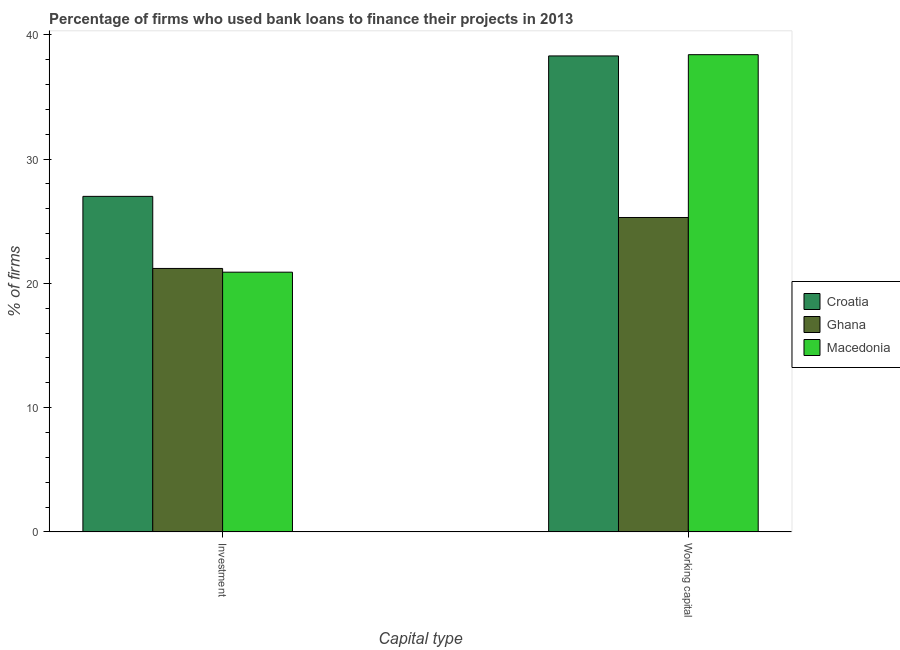How many different coloured bars are there?
Provide a succinct answer. 3. How many groups of bars are there?
Give a very brief answer. 2. What is the label of the 2nd group of bars from the left?
Your answer should be very brief. Working capital. What is the percentage of firms using banks to finance investment in Ghana?
Give a very brief answer. 21.2. Across all countries, what is the maximum percentage of firms using banks to finance working capital?
Keep it short and to the point. 38.4. Across all countries, what is the minimum percentage of firms using banks to finance working capital?
Keep it short and to the point. 25.3. In which country was the percentage of firms using banks to finance investment maximum?
Offer a very short reply. Croatia. What is the total percentage of firms using banks to finance working capital in the graph?
Your answer should be very brief. 102. What is the difference between the percentage of firms using banks to finance investment in Croatia and that in Ghana?
Your answer should be very brief. 5.8. What is the difference between the percentage of firms using banks to finance investment in Macedonia and the percentage of firms using banks to finance working capital in Croatia?
Keep it short and to the point. -17.4. What is the average percentage of firms using banks to finance working capital per country?
Your response must be concise. 34. What is the difference between the percentage of firms using banks to finance investment and percentage of firms using banks to finance working capital in Macedonia?
Ensure brevity in your answer.  -17.5. In how many countries, is the percentage of firms using banks to finance working capital greater than 20 %?
Ensure brevity in your answer.  3. What is the ratio of the percentage of firms using banks to finance working capital in Macedonia to that in Ghana?
Keep it short and to the point. 1.52. In how many countries, is the percentage of firms using banks to finance investment greater than the average percentage of firms using banks to finance investment taken over all countries?
Give a very brief answer. 1. What does the 1st bar from the right in Working capital represents?
Your answer should be compact. Macedonia. How many countries are there in the graph?
Provide a succinct answer. 3. Does the graph contain any zero values?
Offer a very short reply. No. Does the graph contain grids?
Your answer should be compact. No. Where does the legend appear in the graph?
Make the answer very short. Center right. How are the legend labels stacked?
Give a very brief answer. Vertical. What is the title of the graph?
Offer a very short reply. Percentage of firms who used bank loans to finance their projects in 2013. Does "Turkmenistan" appear as one of the legend labels in the graph?
Give a very brief answer. No. What is the label or title of the X-axis?
Keep it short and to the point. Capital type. What is the label or title of the Y-axis?
Ensure brevity in your answer.  % of firms. What is the % of firms in Croatia in Investment?
Your response must be concise. 27. What is the % of firms in Ghana in Investment?
Offer a very short reply. 21.2. What is the % of firms in Macedonia in Investment?
Offer a very short reply. 20.9. What is the % of firms in Croatia in Working capital?
Give a very brief answer. 38.3. What is the % of firms of Ghana in Working capital?
Offer a terse response. 25.3. What is the % of firms in Macedonia in Working capital?
Offer a terse response. 38.4. Across all Capital type, what is the maximum % of firms of Croatia?
Offer a terse response. 38.3. Across all Capital type, what is the maximum % of firms of Ghana?
Your answer should be compact. 25.3. Across all Capital type, what is the maximum % of firms in Macedonia?
Give a very brief answer. 38.4. Across all Capital type, what is the minimum % of firms of Croatia?
Ensure brevity in your answer.  27. Across all Capital type, what is the minimum % of firms in Ghana?
Keep it short and to the point. 21.2. Across all Capital type, what is the minimum % of firms of Macedonia?
Make the answer very short. 20.9. What is the total % of firms of Croatia in the graph?
Your answer should be compact. 65.3. What is the total % of firms of Ghana in the graph?
Ensure brevity in your answer.  46.5. What is the total % of firms of Macedonia in the graph?
Your response must be concise. 59.3. What is the difference between the % of firms of Croatia in Investment and that in Working capital?
Offer a terse response. -11.3. What is the difference between the % of firms of Ghana in Investment and that in Working capital?
Keep it short and to the point. -4.1. What is the difference between the % of firms in Macedonia in Investment and that in Working capital?
Provide a short and direct response. -17.5. What is the difference between the % of firms of Croatia in Investment and the % of firms of Ghana in Working capital?
Provide a succinct answer. 1.7. What is the difference between the % of firms of Ghana in Investment and the % of firms of Macedonia in Working capital?
Provide a succinct answer. -17.2. What is the average % of firms in Croatia per Capital type?
Your answer should be compact. 32.65. What is the average % of firms of Ghana per Capital type?
Offer a very short reply. 23.25. What is the average % of firms in Macedonia per Capital type?
Offer a very short reply. 29.65. What is the difference between the % of firms in Croatia and % of firms in Macedonia in Investment?
Offer a very short reply. 6.1. What is the difference between the % of firms of Ghana and % of firms of Macedonia in Investment?
Provide a short and direct response. 0.3. What is the difference between the % of firms of Croatia and % of firms of Macedonia in Working capital?
Your answer should be very brief. -0.1. What is the difference between the % of firms of Ghana and % of firms of Macedonia in Working capital?
Provide a succinct answer. -13.1. What is the ratio of the % of firms in Croatia in Investment to that in Working capital?
Ensure brevity in your answer.  0.7. What is the ratio of the % of firms of Ghana in Investment to that in Working capital?
Ensure brevity in your answer.  0.84. What is the ratio of the % of firms of Macedonia in Investment to that in Working capital?
Keep it short and to the point. 0.54. What is the difference between the highest and the second highest % of firms in Ghana?
Offer a terse response. 4.1. What is the difference between the highest and the lowest % of firms of Ghana?
Offer a very short reply. 4.1. What is the difference between the highest and the lowest % of firms in Macedonia?
Ensure brevity in your answer.  17.5. 